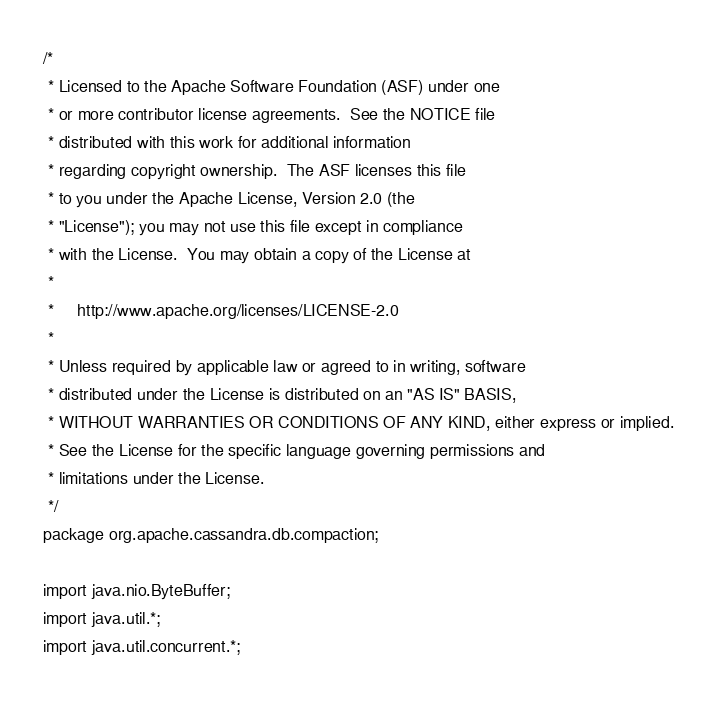<code> <loc_0><loc_0><loc_500><loc_500><_Java_>/*
 * Licensed to the Apache Software Foundation (ASF) under one
 * or more contributor license agreements.  See the NOTICE file
 * distributed with this work for additional information
 * regarding copyright ownership.  The ASF licenses this file
 * to you under the Apache License, Version 2.0 (the
 * "License"); you may not use this file except in compliance
 * with the License.  You may obtain a copy of the License at
 *
 *     http://www.apache.org/licenses/LICENSE-2.0
 *
 * Unless required by applicable law or agreed to in writing, software
 * distributed under the License is distributed on an "AS IS" BASIS,
 * WITHOUT WARRANTIES OR CONDITIONS OF ANY KIND, either express or implied.
 * See the License for the specific language governing permissions and
 * limitations under the License.
 */
package org.apache.cassandra.db.compaction;

import java.nio.ByteBuffer;
import java.util.*;
import java.util.concurrent.*;
</code> 